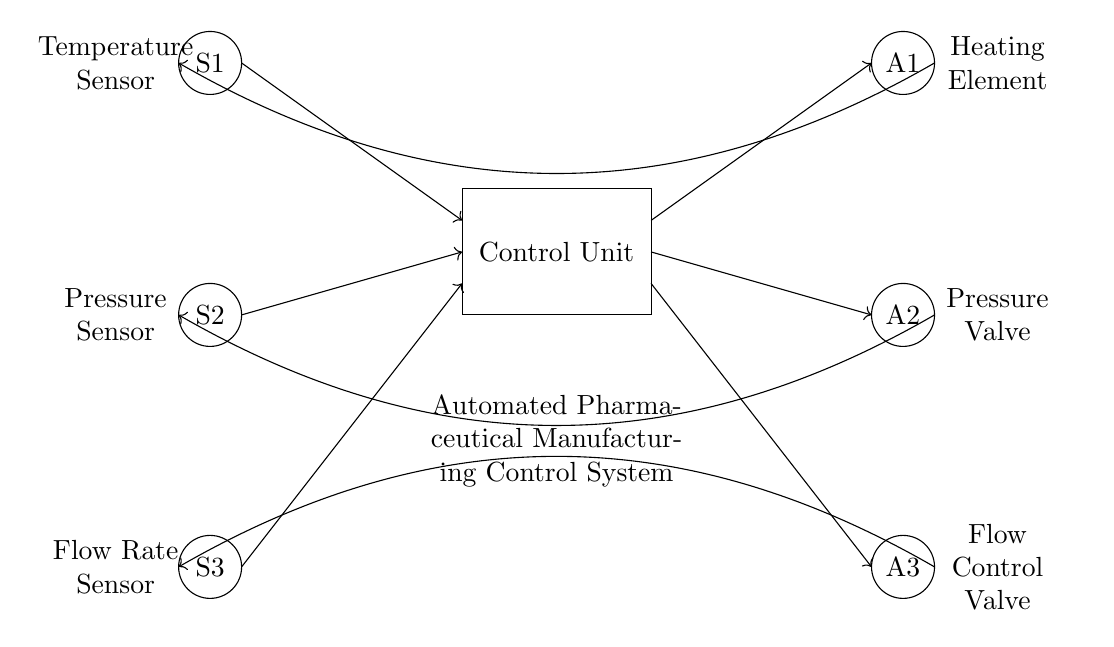What are the sensors present in this circuit? The circuit diagram shows three sensors (S1, S2, S3), specifically: Temperature Sensor (S1), Pressure Sensor (S2), and Flow Rate Sensor (S3). These components are depicted as circles labeled in the upper left corner of the diagram.
Answer: Temperature Sensor, Pressure Sensor, Flow Rate Sensor What type of components are A1, A2, and A3? A1, A2, and A3 are actuators. By checking the right side of the circuit diagram, you can see they are labeled as Heating Element (A1), Pressure Valve (A2), and Flow Control Valve (A3). These components are shown as circles in the right section of the diagram.
Answer: Actuators How many feedback loops are present in the circuit? The circuit has three feedback loops, which can be identified by the arrows bending towards the sensors from each actuator. Each actuator has a feedback connection leading back to the corresponding sensor: A1 to S1, A2 to S2, and A3 to S3.
Answer: Three Which actuator responds to the temperature sensor? The actuator that responds to the temperature sensor (S1) is the Heating Element (A1). In the diagram, there is a direct feedback loop from A1 that connects back to S1, indicating a control relationship.
Answer: Heating Element What is the main function of the Control Unit? The Control Unit is responsible for processing the data from the sensors and coordinating the responses of the actuators based on that data. In this diagram, it serves as the central component which integrates input from multiple sensors and sends output to actuators accordingly.
Answer: Coordination What is the role of feedback loops in this control system? Feedback loops in this control system help maintain system stability by allowing the Control Unit to adjust actuator outputs based on real-time sensor data. This ensures the proper operation of the manufacturing process by continuously monitoring and regulating the conditions according to the readings from S1, S2, and S3.
Answer: Stability 